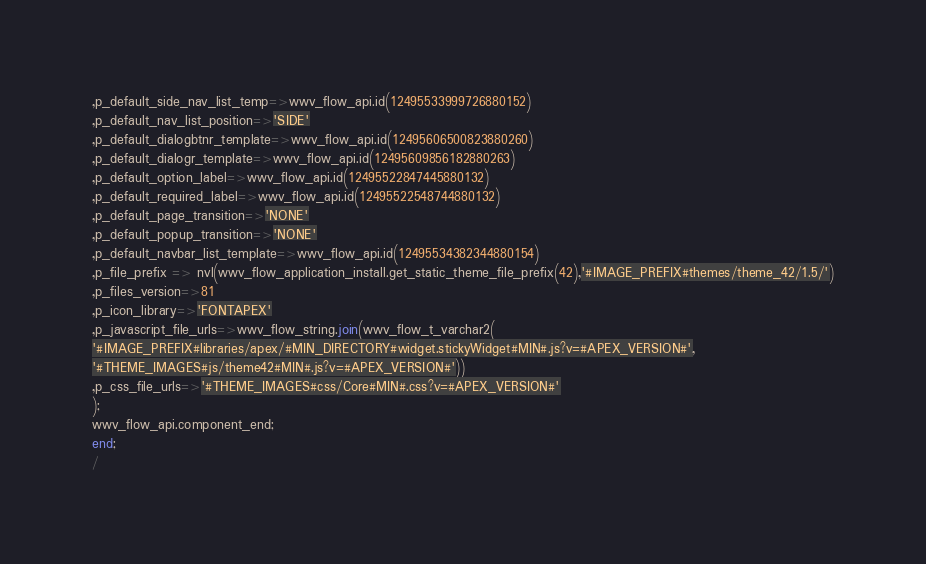<code> <loc_0><loc_0><loc_500><loc_500><_SQL_>,p_default_side_nav_list_temp=>wwv_flow_api.id(12495533999726880152)
,p_default_nav_list_position=>'SIDE'
,p_default_dialogbtnr_template=>wwv_flow_api.id(12495606500823880260)
,p_default_dialogr_template=>wwv_flow_api.id(12495609856182880263)
,p_default_option_label=>wwv_flow_api.id(12495522847445880132)
,p_default_required_label=>wwv_flow_api.id(12495522548744880132)
,p_default_page_transition=>'NONE'
,p_default_popup_transition=>'NONE'
,p_default_navbar_list_template=>wwv_flow_api.id(12495534382344880154)
,p_file_prefix => nvl(wwv_flow_application_install.get_static_theme_file_prefix(42),'#IMAGE_PREFIX#themes/theme_42/1.5/')
,p_files_version=>81
,p_icon_library=>'FONTAPEX'
,p_javascript_file_urls=>wwv_flow_string.join(wwv_flow_t_varchar2(
'#IMAGE_PREFIX#libraries/apex/#MIN_DIRECTORY#widget.stickyWidget#MIN#.js?v=#APEX_VERSION#',
'#THEME_IMAGES#js/theme42#MIN#.js?v=#APEX_VERSION#'))
,p_css_file_urls=>'#THEME_IMAGES#css/Core#MIN#.css?v=#APEX_VERSION#'
);
wwv_flow_api.component_end;
end;
/
</code> 